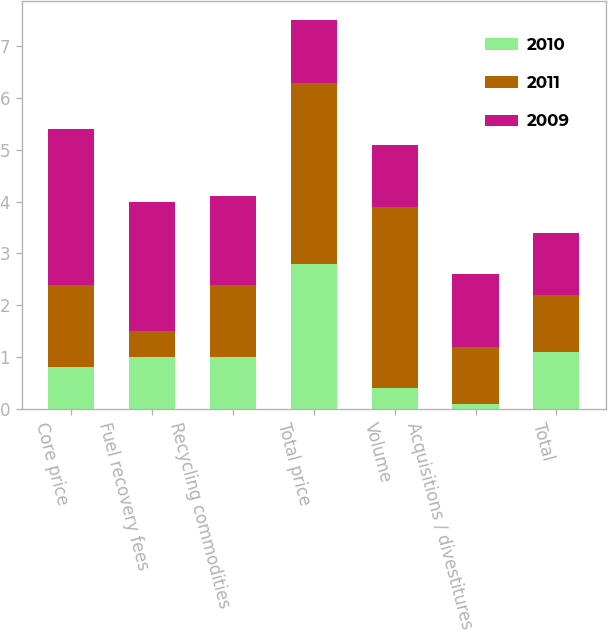<chart> <loc_0><loc_0><loc_500><loc_500><stacked_bar_chart><ecel><fcel>Core price<fcel>Fuel recovery fees<fcel>Recycling commodities<fcel>Total price<fcel>Volume<fcel>Acquisitions / divestitures<fcel>Total<nl><fcel>2010<fcel>0.8<fcel>1<fcel>1<fcel>2.8<fcel>0.4<fcel>0.1<fcel>1.1<nl><fcel>2011<fcel>1.6<fcel>0.5<fcel>1.4<fcel>3.5<fcel>3.5<fcel>1.1<fcel>1.1<nl><fcel>2009<fcel>3<fcel>2.5<fcel>1.7<fcel>1.2<fcel>1.2<fcel>1.4<fcel>1.2<nl></chart> 